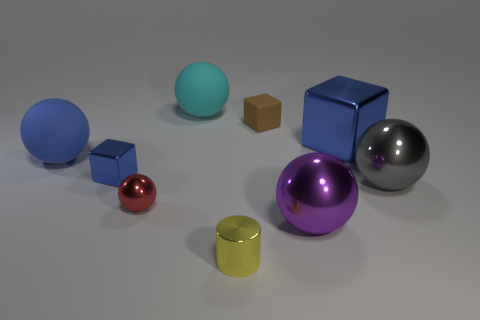Subtract all cyan spheres. How many spheres are left? 4 Subtract all red balls. How many balls are left? 4 Subtract 2 spheres. How many spheres are left? 3 Subtract all brown balls. Subtract all blue cylinders. How many balls are left? 5 Add 1 cylinders. How many objects exist? 10 Subtract all spheres. How many objects are left? 4 Subtract 0 yellow cubes. How many objects are left? 9 Subtract all metal cylinders. Subtract all red metal objects. How many objects are left? 7 Add 9 big blue metal blocks. How many big blue metal blocks are left? 10 Add 4 tiny cylinders. How many tiny cylinders exist? 5 